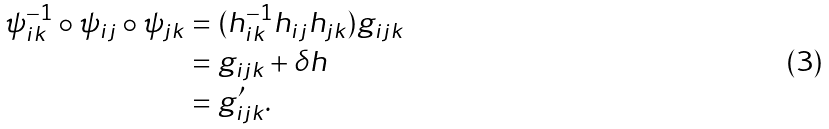<formula> <loc_0><loc_0><loc_500><loc_500>\psi ^ { - 1 } _ { i k } \circ \psi _ { i j } \circ \psi _ { j k } & = ( h ^ { - 1 } _ { i k } h _ { i j } h _ { j k } ) g _ { i j k } \\ & = g _ { i j k } + \delta h \\ & = g ^ { \prime } _ { i j k } .</formula> 